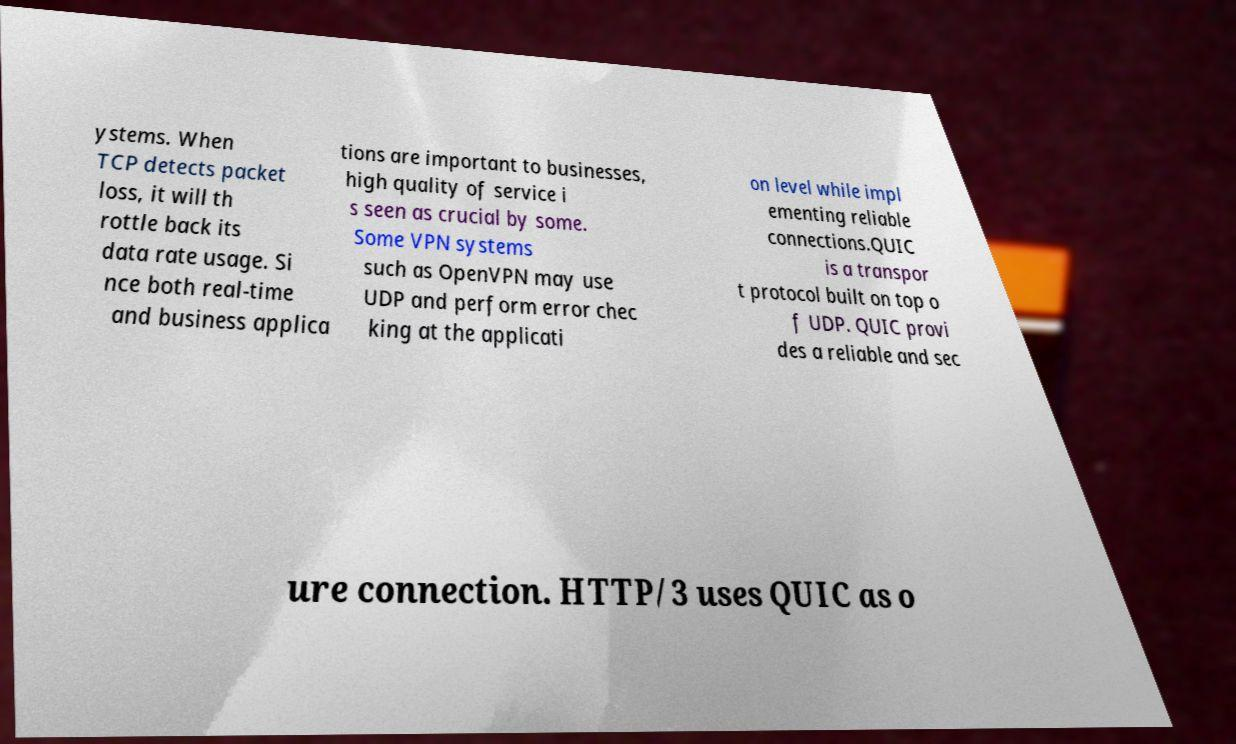What messages or text are displayed in this image? I need them in a readable, typed format. ystems. When TCP detects packet loss, it will th rottle back its data rate usage. Si nce both real-time and business applica tions are important to businesses, high quality of service i s seen as crucial by some. Some VPN systems such as OpenVPN may use UDP and perform error chec king at the applicati on level while impl ementing reliable connections.QUIC is a transpor t protocol built on top o f UDP. QUIC provi des a reliable and sec ure connection. HTTP/3 uses QUIC as o 